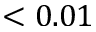<formula> <loc_0><loc_0><loc_500><loc_500>< 0 . 0 1</formula> 